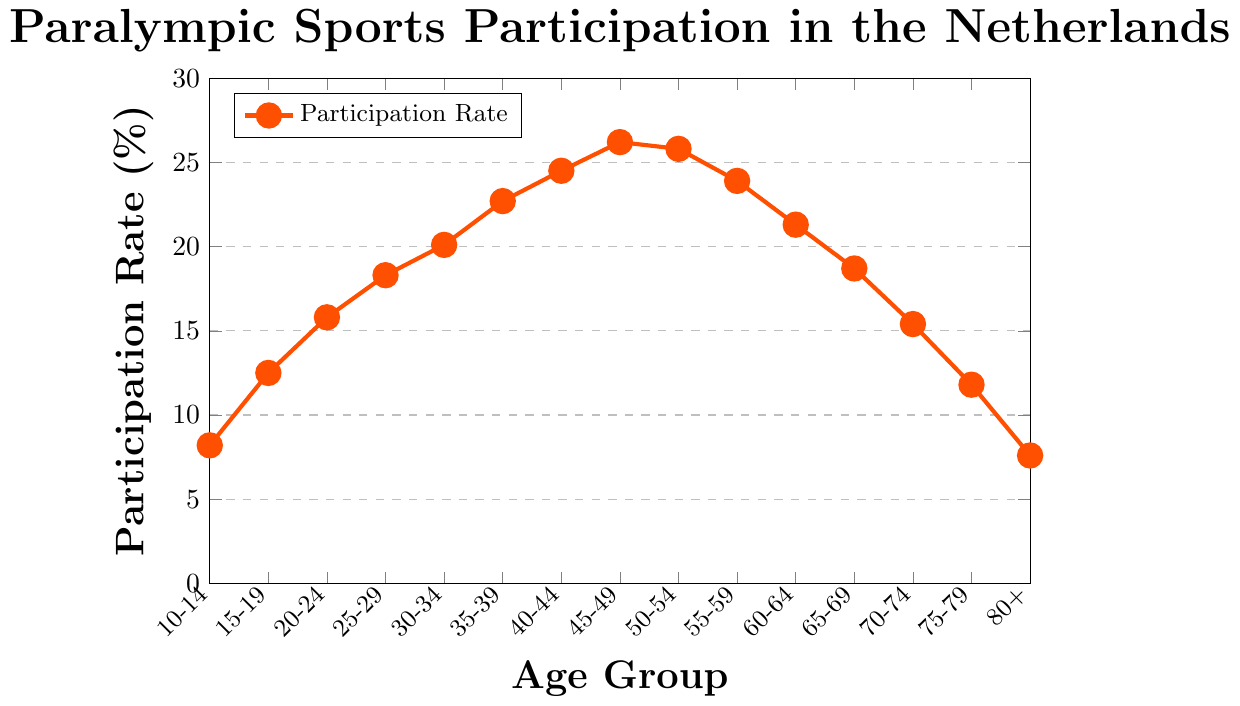What is the participation rate for the 30-34 age group? To find the participation rate for the 30-34 age group, locate the corresponding age group label on the X-axis and read the value on the Y-axis.
Answer: 20.1% Which age group has the highest participation rate in Paralympic sports? To find the age group with the highest participation rate, identify the point on the line chart with the highest Y-axis value.
Answer: 45-49 Compare the participation rates of the 15-19 and 75-79 age groups. Which one is higher and by how much? Locate the participation rate values for both age groups on the Y-axis and subtract the lower rate from the higher rate: 12.5% (15-19) - 11.8% (75-79) = 0.7%.
Answer: 15-19 by 0.7% What is the trend in participation rates from the 10-14 age group to the 45-49 age group? Observe whether the participation rates increase, decrease, or remain constant as the age group progresses from 10-14 to 45-49.
Answer: Increasing What is the range of participation rates observed in the chart? To determine the range, subtract the minimum participation rate from the maximum participation rate: 26.2% (maximum) - 7.6% (minimum) = 18.6%.
Answer: 18.6% Describe how the participation rate changes as age increases from 50-54 to 80+. Note the changes in participation rates for the age groups from 50-54 to 80+ by observing the line's slope. The participation rate decreases from 25.8% to 7.6%.
Answer: It decreases For which age groups does the participation rate exceed 20%? Identify the age groups whose participation rates are above 20% by checking the Y-axis values.
Answer: 30-34, 35-39, 40-44, 45-49, 50-54 Which age group has the lowest participation rate, and what is that rate? Locate the point with the lowest Y-axis value and find the corresponding age group and rate.
Answer: 80+, 7.6% Calculate the average participation rate for the age groups 35-39, 40-44, and 45-49. Add the participation rates of the age groups and divide by 3: (22.7% + 24.5% + 26.2%) / 3 ≈ 24.5%.
Answer: 24.5% What is the difference in the participation rate between the 60-64 and 65-69 age groups? Subtract the participation rate of the 65-69 age group from the 60-64 age group: 21.3% - 18.7% = 2.6%.
Answer: 2.6% 